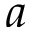Convert formula to latex. <formula><loc_0><loc_0><loc_500><loc_500>a</formula> 